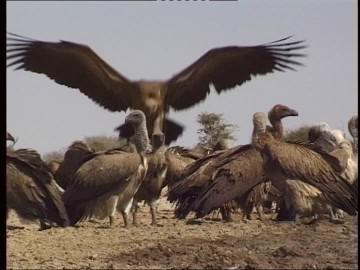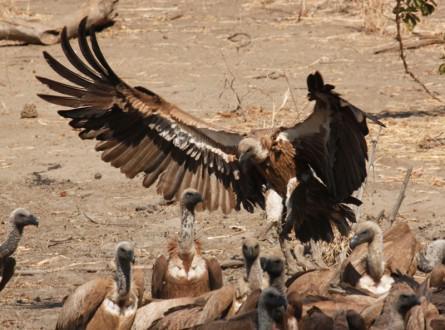The first image is the image on the left, the second image is the image on the right. For the images displayed, is the sentence "An image shows exactly two vultures with sky-blue background." factually correct? Answer yes or no. No. The first image is the image on the left, the second image is the image on the right. For the images shown, is this caption "One of the images shows exactly two birds." true? Answer yes or no. No. 